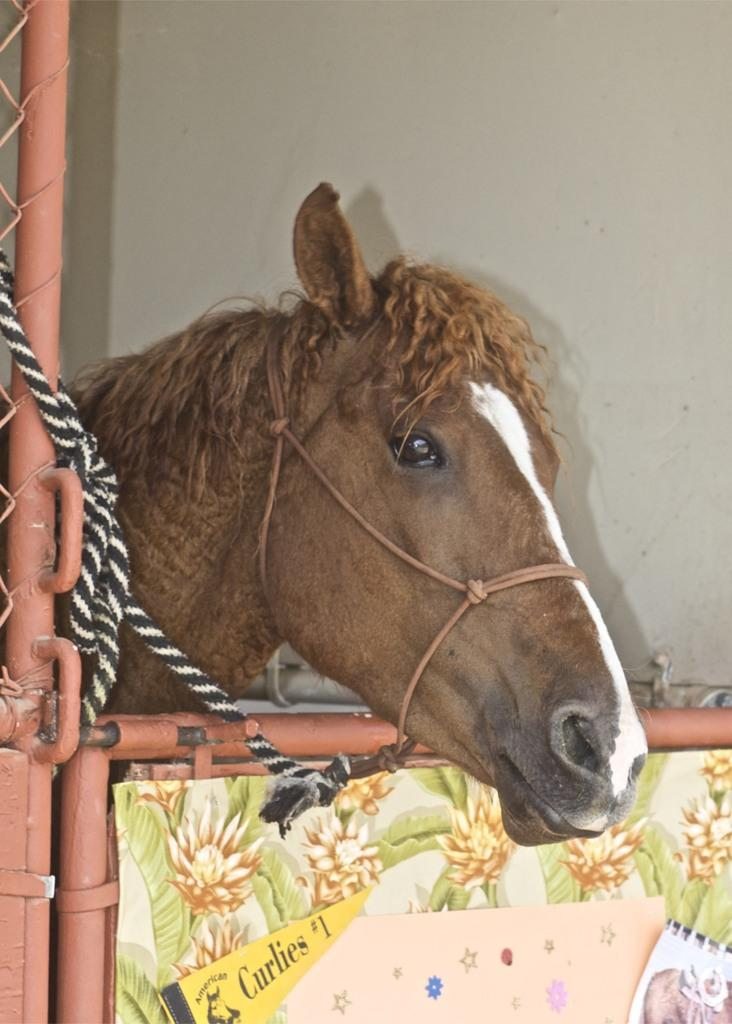What animal can be seen in the image? There is a horse in the image. What structures are present in the image? There is a pole, a fence, a rope, a gate, a poster with text, images on the poster, and a wall in the image. Can you describe the poster in the image? The poster in the image has text and images on it. What is the horse's location in relation to the other structures in the image? The horse is near the pole, fence, rope, gate, and wall in the image. How much money is the horse holding in the image? The horse is not holding any money in the image. What type of scale is used to weigh the horse in the image? There is no scale present in the image, and the horse is not being weighed. 